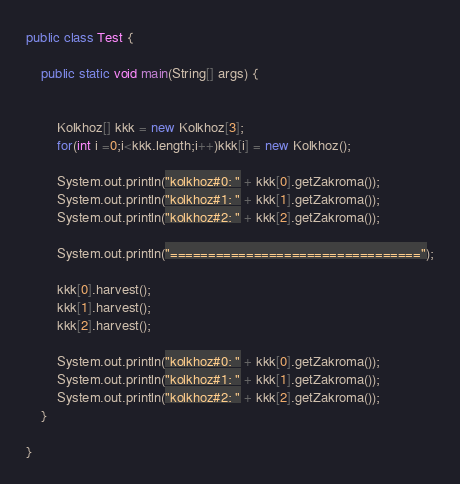<code> <loc_0><loc_0><loc_500><loc_500><_Java_>
public class Test {

	public static void main(String[] args) {
		
		
		Kolkhoz[] kkk = new Kolkhoz[3];
		for(int i =0;i<kkk.length;i++)kkk[i] = new Kolkhoz();
		
		System.out.println("kolkhoz#0: " + kkk[0].getZakroma());
		System.out.println("kolkhoz#1: " + kkk[1].getZakroma());
		System.out.println("kolkhoz#2: " + kkk[2].getZakroma());
		
		System.out.println("=================================");
		
		kkk[0].harvest();
		kkk[1].harvest();
		kkk[2].harvest();
		
		System.out.println("kolkhoz#0: " + kkk[0].getZakroma());
		System.out.println("kolkhoz#1: " + kkk[1].getZakroma());
		System.out.println("kolkhoz#2: " + kkk[2].getZakroma());
	}

}
</code> 